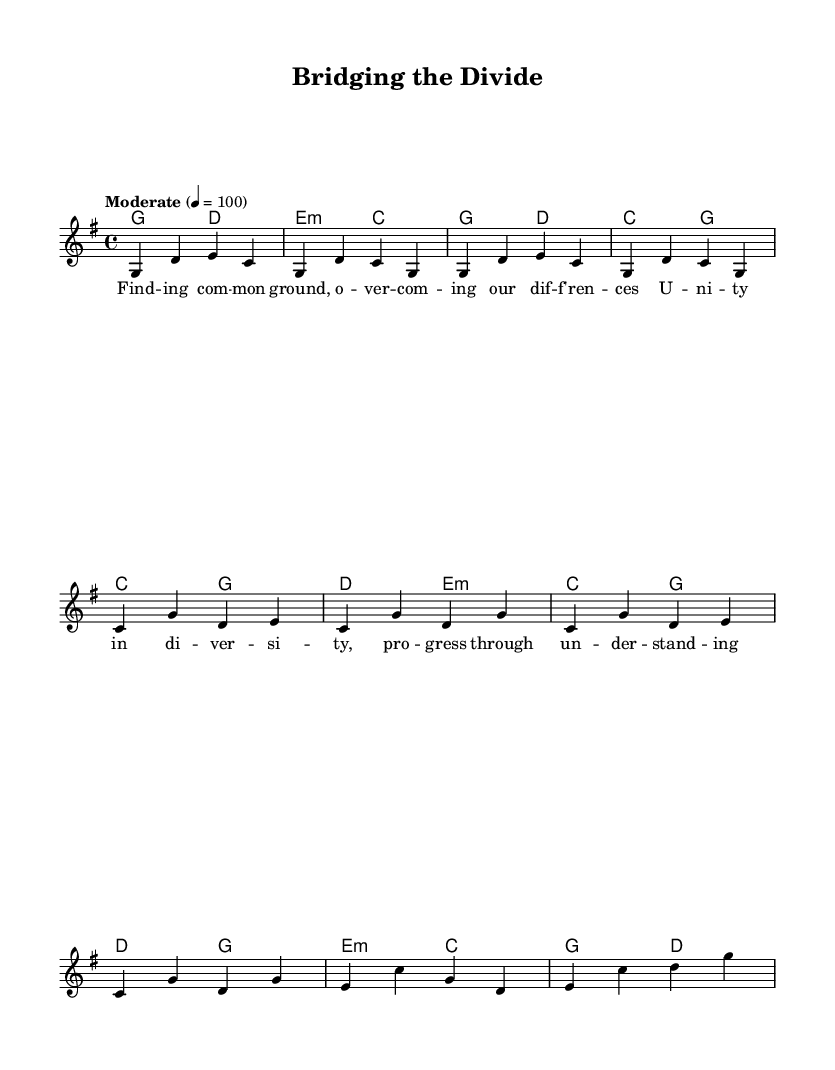What is the key signature of this music? The key signature is G major, which has one sharp (F sharp). This can be identified by looking at the key signature notated at the beginning of the sheet music, where a single sharp symbol appears.
Answer: G major What is the time signature of the piece? The time signature is 4/4, indicated in the beginning of the score. This means there are four beats in a measure, and the quarter note gets one beat, which is displayed by the "4" over "4".
Answer: 4/4 What is the tempo marking for the piece? The tempo marking is "Moderate" at a speed of 100 beats per minute. This is stated above the score, which helps musicians understand how fast to play the piece.
Answer: Moderate 100 How many measures are in the verse? The verse consists of four measures. This can be counted by identifying each vertical line (bar line) in the melody section, which separates the measures.
Answer: Four What chord is played during the chorus that is not in the verse? The chord D minor is played during the chorus (e2:m), which is not present in the verse section of the piece. When analyzing the harmonies, this specific chord is listed in the chorus while the verse contains only major and another minor chord.
Answer: D minor What is the primary lyrical theme in the chorus? The primary lyrical theme in the chorus is unity in diversity, which promotes a message of solidarity and understanding amidst differences. This is directly derived from the words that appear in the lyrics section of the chorus.
Answer: Unity in diversity How does the bridge relate to the overall song structure? The bridge serves as a contrasting section that provides variety and leads back to the chorus, creating a sense of tension and resolution. By examining the layout of the score, the bridge connects different sections and emphasizes the song’s message about overcoming differences.
Answer: Contrasting section leading back to the chorus 